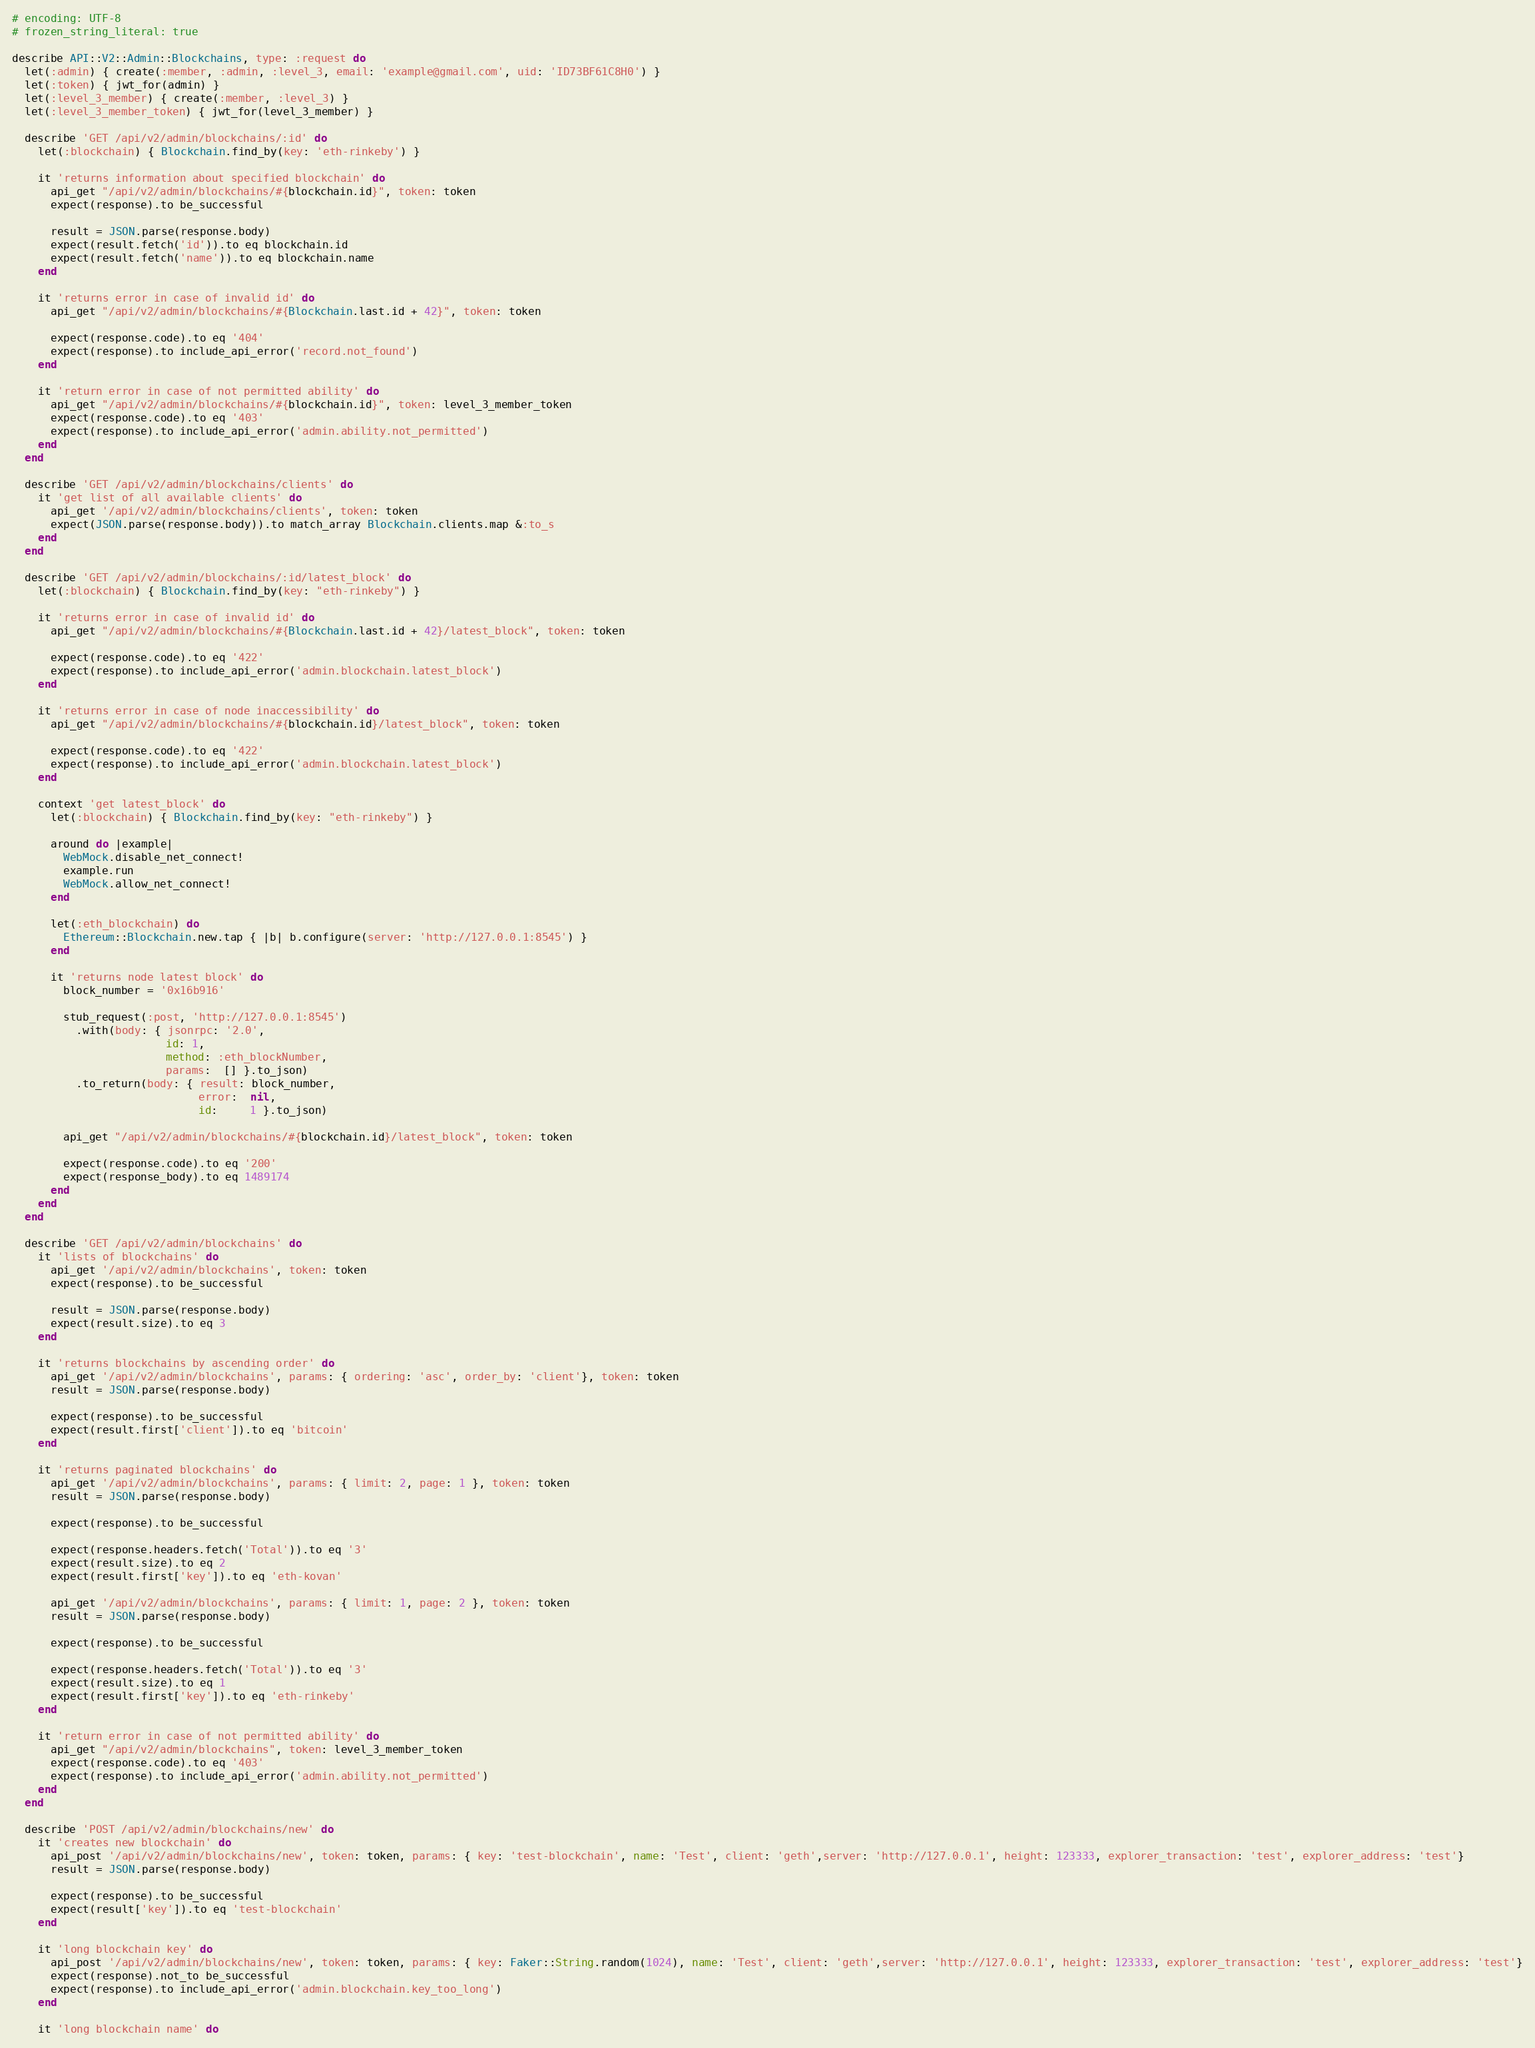<code> <loc_0><loc_0><loc_500><loc_500><_Ruby_># encoding: UTF-8
# frozen_string_literal: true

describe API::V2::Admin::Blockchains, type: :request do
  let(:admin) { create(:member, :admin, :level_3, email: 'example@gmail.com', uid: 'ID73BF61C8H0') }
  let(:token) { jwt_for(admin) }
  let(:level_3_member) { create(:member, :level_3) }
  let(:level_3_member_token) { jwt_for(level_3_member) }

  describe 'GET /api/v2/admin/blockchains/:id' do
    let(:blockchain) { Blockchain.find_by(key: 'eth-rinkeby') }

    it 'returns information about specified blockchain' do
      api_get "/api/v2/admin/blockchains/#{blockchain.id}", token: token
      expect(response).to be_successful

      result = JSON.parse(response.body)
      expect(result.fetch('id')).to eq blockchain.id
      expect(result.fetch('name')).to eq blockchain.name
    end

    it 'returns error in case of invalid id' do
      api_get "/api/v2/admin/blockchains/#{Blockchain.last.id + 42}", token: token

      expect(response.code).to eq '404'
      expect(response).to include_api_error('record.not_found')
    end

    it 'return error in case of not permitted ability' do
      api_get "/api/v2/admin/blockchains/#{blockchain.id}", token: level_3_member_token
      expect(response.code).to eq '403'
      expect(response).to include_api_error('admin.ability.not_permitted')
    end
  end

  describe 'GET /api/v2/admin/blockchains/clients' do
    it 'get list of all available clients' do
      api_get '/api/v2/admin/blockchains/clients', token: token
      expect(JSON.parse(response.body)).to match_array Blockchain.clients.map &:to_s
    end
  end

  describe 'GET /api/v2/admin/blockchains/:id/latest_block' do
    let(:blockchain) { Blockchain.find_by(key: "eth-rinkeby") }

    it 'returns error in case of invalid id' do
      api_get "/api/v2/admin/blockchains/#{Blockchain.last.id + 42}/latest_block", token: token

      expect(response.code).to eq '422'
      expect(response).to include_api_error('admin.blockchain.latest_block')
    end

    it 'returns error in case of node inaccessibility' do
      api_get "/api/v2/admin/blockchains/#{blockchain.id}/latest_block", token: token

      expect(response.code).to eq '422'
      expect(response).to include_api_error('admin.blockchain.latest_block')
    end

    context 'get latest_block' do
      let(:blockchain) { Blockchain.find_by(key: "eth-rinkeby") }

      around do |example|
        WebMock.disable_net_connect!
        example.run
        WebMock.allow_net_connect!
      end

      let(:eth_blockchain) do
        Ethereum::Blockchain.new.tap { |b| b.configure(server: 'http://127.0.0.1:8545') }
      end

      it 'returns node latest block' do
        block_number = '0x16b916'

        stub_request(:post, 'http://127.0.0.1:8545')
          .with(body: { jsonrpc: '2.0',
                        id: 1,
                        method: :eth_blockNumber,
                        params:  [] }.to_json)
          .to_return(body: { result: block_number,
                             error:  nil,
                             id:     1 }.to_json)

        api_get "/api/v2/admin/blockchains/#{blockchain.id}/latest_block", token: token

        expect(response.code).to eq '200'
        expect(response_body).to eq 1489174
      end
    end
  end

  describe 'GET /api/v2/admin/blockchains' do
    it 'lists of blockchains' do
      api_get '/api/v2/admin/blockchains', token: token
      expect(response).to be_successful

      result = JSON.parse(response.body)
      expect(result.size).to eq 3
    end

    it 'returns blockchains by ascending order' do
      api_get '/api/v2/admin/blockchains', params: { ordering: 'asc', order_by: 'client'}, token: token
      result = JSON.parse(response.body)

      expect(response).to be_successful
      expect(result.first['client']).to eq 'bitcoin'
    end

    it 'returns paginated blockchains' do
      api_get '/api/v2/admin/blockchains', params: { limit: 2, page: 1 }, token: token
      result = JSON.parse(response.body)

      expect(response).to be_successful

      expect(response.headers.fetch('Total')).to eq '3'
      expect(result.size).to eq 2
      expect(result.first['key']).to eq 'eth-kovan'

      api_get '/api/v2/admin/blockchains', params: { limit: 1, page: 2 }, token: token
      result = JSON.parse(response.body)

      expect(response).to be_successful

      expect(response.headers.fetch('Total')).to eq '3'
      expect(result.size).to eq 1
      expect(result.first['key']).to eq 'eth-rinkeby'
    end

    it 'return error in case of not permitted ability' do
      api_get "/api/v2/admin/blockchains", token: level_3_member_token
      expect(response.code).to eq '403'
      expect(response).to include_api_error('admin.ability.not_permitted')
    end
  end

  describe 'POST /api/v2/admin/blockchains/new' do
    it 'creates new blockchain' do
      api_post '/api/v2/admin/blockchains/new', token: token, params: { key: 'test-blockchain', name: 'Test', client: 'geth',server: 'http://127.0.0.1', height: 123333, explorer_transaction: 'test', explorer_address: 'test'}
      result = JSON.parse(response.body)

      expect(response).to be_successful
      expect(result['key']).to eq 'test-blockchain'
    end

    it 'long blockchain key' do
      api_post '/api/v2/admin/blockchains/new', token: token, params: { key: Faker::String.random(1024), name: 'Test', client: 'geth',server: 'http://127.0.0.1', height: 123333, explorer_transaction: 'test', explorer_address: 'test'}
      expect(response).not_to be_successful
      expect(response).to include_api_error('admin.blockchain.key_too_long')
    end

    it 'long blockchain name' do</code> 